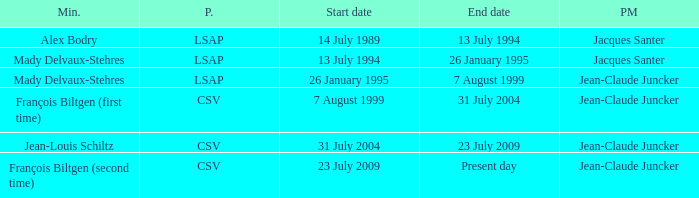Which minister represented the csv party and has a current end date? François Biltgen (second time). 